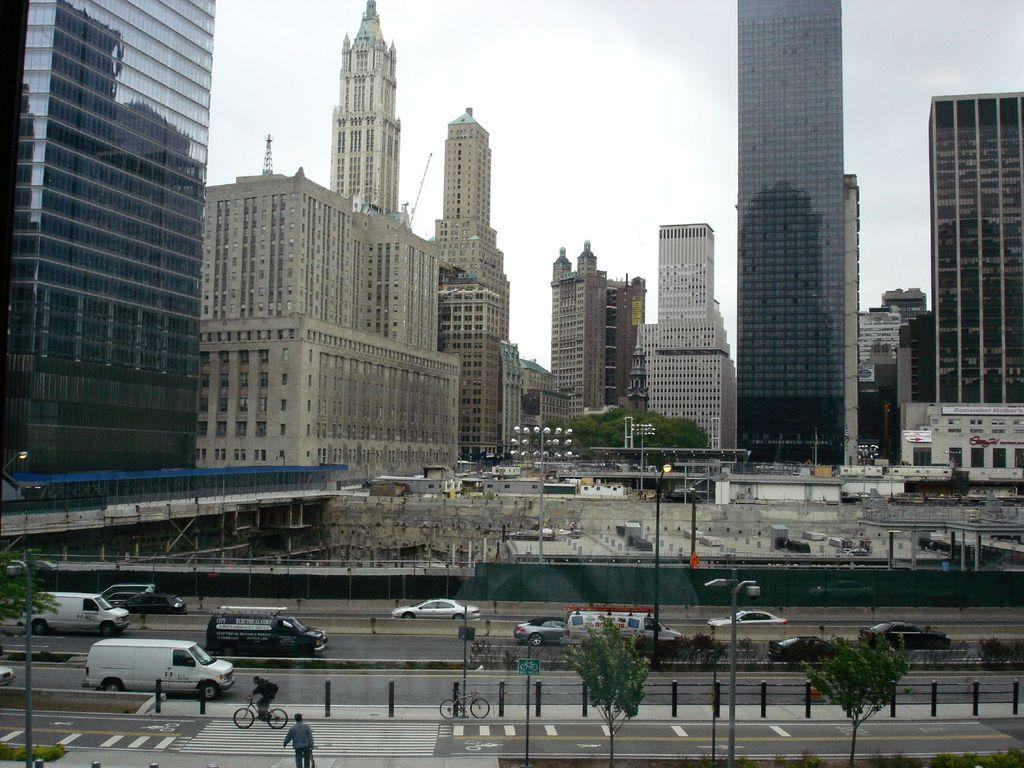What type of structures can be seen in the image? There are buildings in the image. What part of the natural environment is visible in the image? The sky is visible in the image. What type of artificial light sources can be seen in the image? There are lights and a street lamp visible in the image. What type of transportation is present in the image? Vehicles are present in the image. What type of activity can be seen involving people in the image? There are people riding bicycles in the image. What type of natural feature can be seen in the image? There is water visible in the image. Can you tell me how many hands are visible in the image? There are no hands visible in the image. Is there a guide present in the image to help people navigate the area? There is no guide present in the image. 